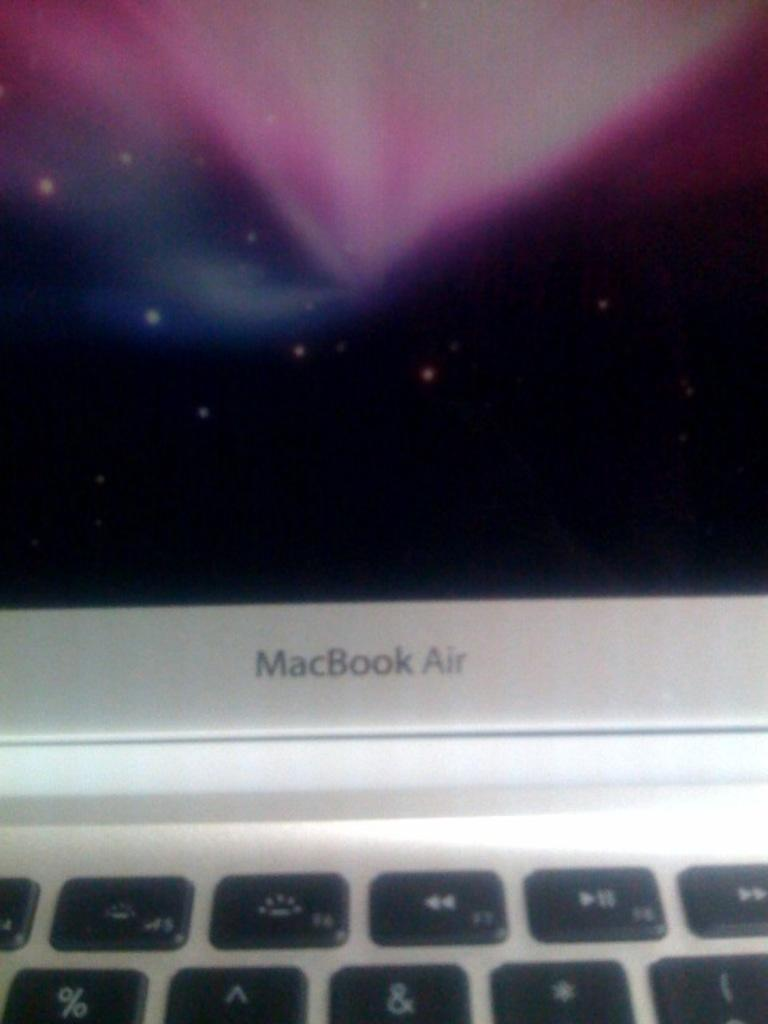<image>
Provide a brief description of the given image. A MacBook Air laptop is open and on. 